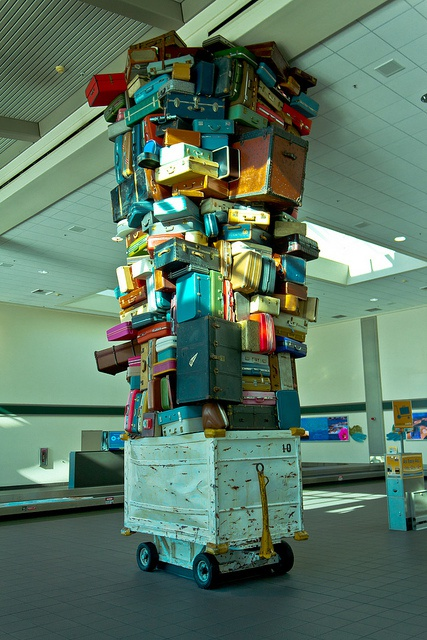Describe the objects in this image and their specific colors. I can see suitcase in olive, black, teal, and maroon tones, suitcase in olive, black, teal, and darkgreen tones, suitcase in olive, black, darkblue, darkgreen, and teal tones, suitcase in olive, maroon, black, and darkgreen tones, and suitcase in olive, black, gray, and maroon tones in this image. 